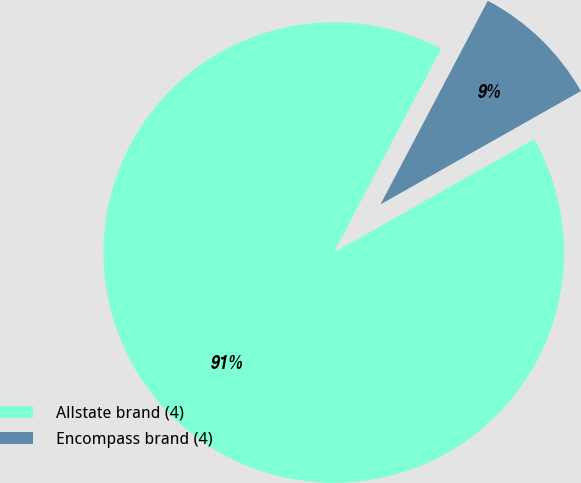Convert chart to OTSL. <chart><loc_0><loc_0><loc_500><loc_500><pie_chart><fcel>Allstate brand (4)<fcel>Encompass brand (4)<nl><fcel>90.91%<fcel>9.09%<nl></chart> 